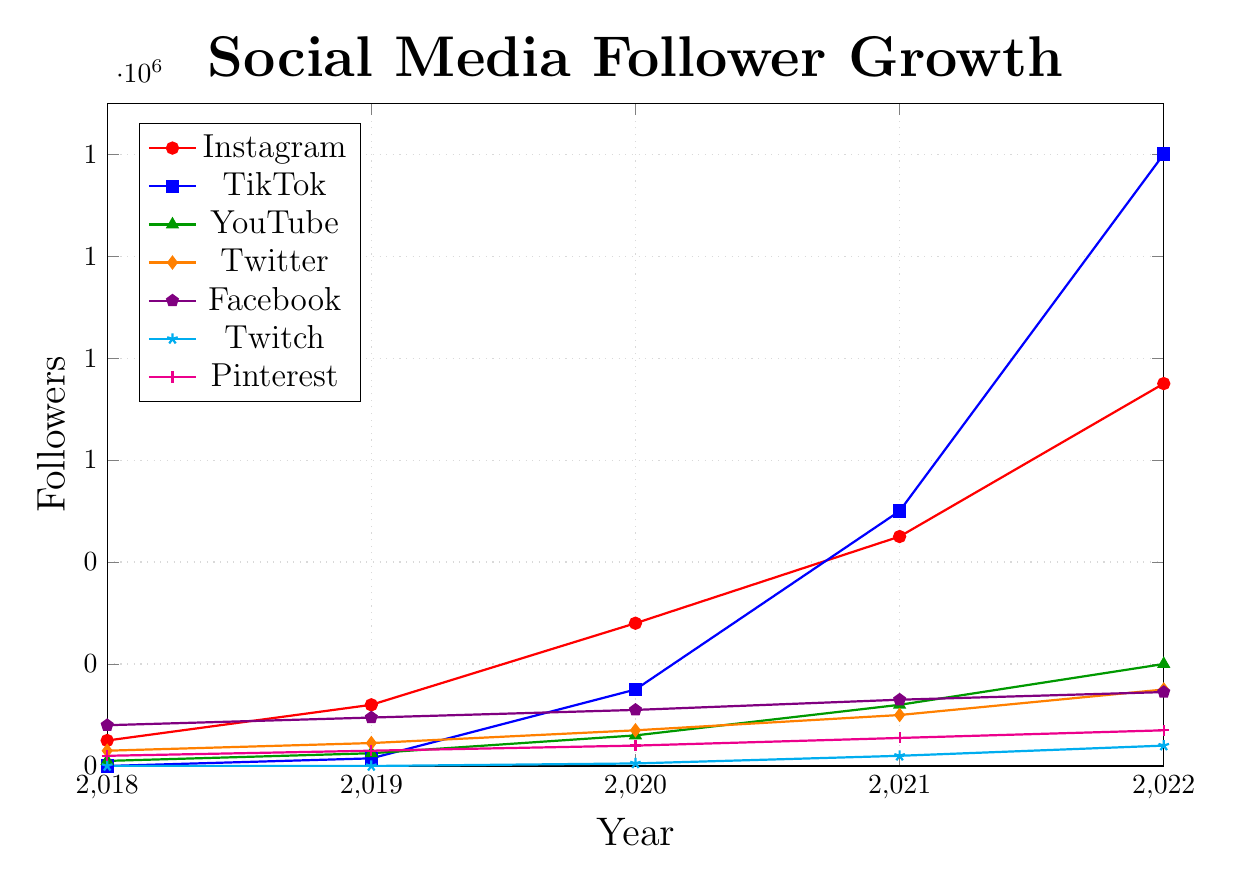What's the platform with the highest follower growth in 2022? By examining the highest point on the y-axis in 2022 for all platforms, TikTok has the most significant number of followers with 1,200,000.
Answer: TikTok Which platform had zero followers in 2018 but showed significant growth later? We look for platforms where the line starts from zero in 2018 and observe their growth in subsequent years. Both TikTok and Twitch had zero followers in 2018, but TikTok showed significant growth.
Answer: TikTok What is the total number of followers across all platforms in 2022? Add the follower counts for 2022 across all platforms: 750,000 (Instagram) + 1,200,000 (TikTok) + 200,000 (YouTube) + 150,000 (Twitter) + 145,000 (Facebook) + 40,000 (Twitch) + 70,000 (Pinterest) = 2,555,000.
Answer: 2,555,000 Between 2019 and 2020, which platform experienced the highest growth rate? Calculate the difference in the number of followers for each platform from 2019 to 2020 and verify the highest value. TikTok grew from 15,000 to 150,000, which is the highest growth rate of +135,000.
Answer: TikTok Which platform had the least growth from 2018 to 2022? Compare follower growth by calculating the difference between 2022 and 2018 for each platform. Twitch went from 0 to 40,000, a growth of 40,000, which is the least among all platforms.
Answer: Twitch Which platform showed consistent growth every year without any declines? Examine the trends for each platform and check for consistency in increasing followers every year. Instagram shows steady yearly growth from 50,000 in 2018 to 750,000 in 2022.
Answer: Instagram Between Instagram and YouTube, which had more followers in 2021? Compare the number of followers in 2021 for both platforms. Instagram had 450,000 followers, whereas YouTube had 120,000 followers.
Answer: Instagram What is the average number of followers for Facebook from 2018 to 2022? Sum the follower counts for Facebook over these years and divide by the number of years: (80,000 + 95,000 + 110,000 + 130,000 + 145,000) / 5 = 112,000.
Answer: 112,000 By how much did TikTok's followers increase from 2020 to 2022? Subtract TikTok's followers in 2020 from its followers in 2022: 1,200,000 - 150,000 = 1,050,000.
Answer: 1,050,000 